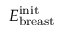Convert formula to latex. <formula><loc_0><loc_0><loc_500><loc_500>E _ { b r e a s t } ^ { i n i t }</formula> 